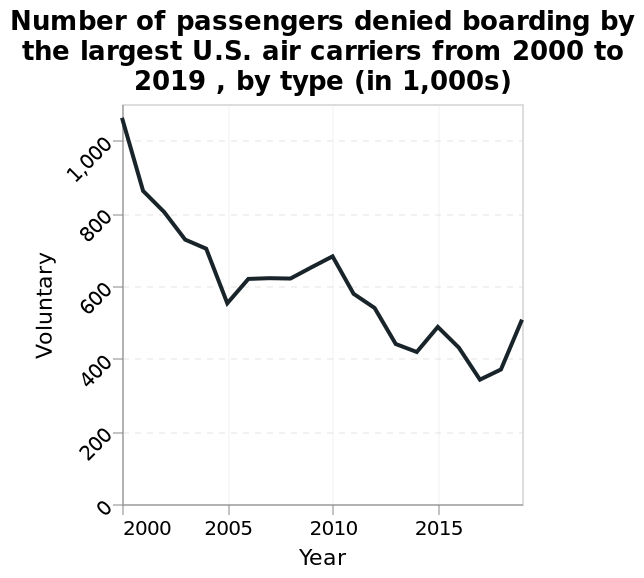<image>
What is the title of the line plot? The title of the line plot is "Number of passengers denied boarding by the largest U.S. air carriers from 2000 to 2019, by type (in 1,000s)." Between which years did the number of passengers denied boarding fall and then rise back up to slightly over the level of 2015? Between 2015 and 2020, the number of passengers denied boarding fell and then rose back up to slightly over the 2015 level. What type of pattern can be observed in the fluctuations of the number of passengers denied boarding during the downward trend? The fluctuations in the number of passengers denied boarding followed a rise-peak-fall pattern during the downward trend. Offer a thorough analysis of the image. Since 2000, the number of passengers denied boarding by the largest US air carriers generally decreased, although there has been a slight upward trend around 2007, which has the lowest value of all the years. There were many fluctuations throughout the downward trend, in which the number of passengers denied boarding increase and then decreased in a rise-peak-fall fashion. For example, between 2015 and 2020, the number fell and then rose back up to slightly over the 2015 level. Did the fluctuations in the number of passengers denied boarding follow a fall-peak-rise pattern during the upward trend? No.The fluctuations in the number of passengers denied boarding followed a rise-peak-fall pattern during the downward trend. 